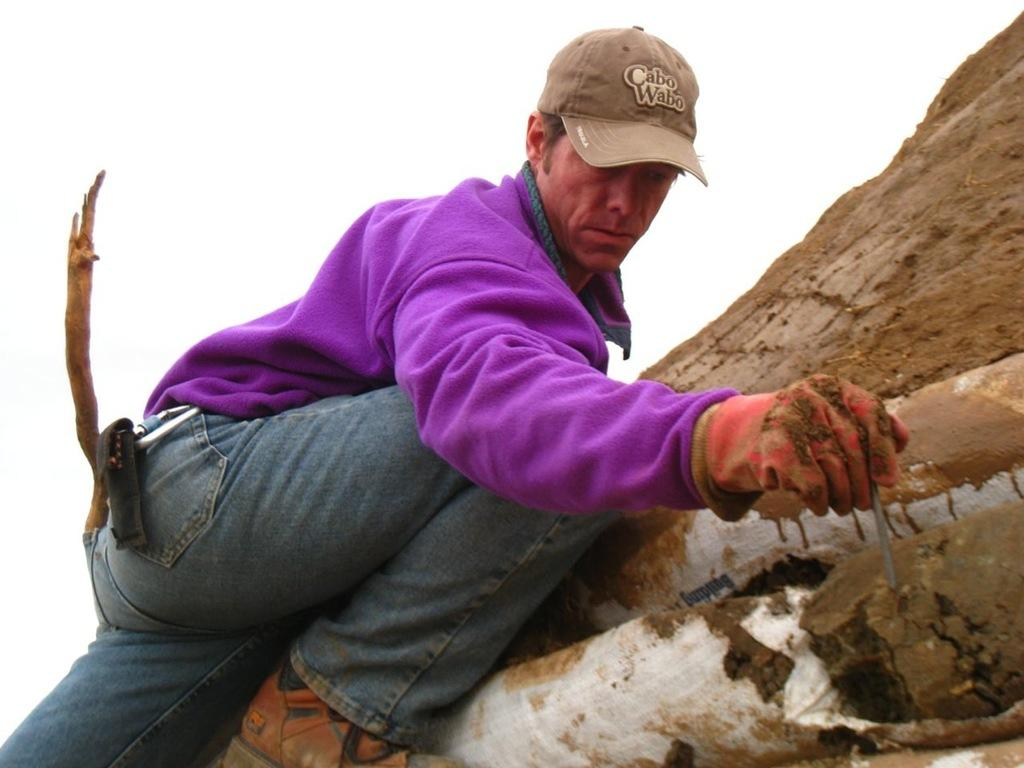What is the main subject of the image? There is a person in the image. What is the person doing in the image? The person is climbing a mountain. What color is the person's shirt? The person is wearing a purple shirt. What color are the person's jeans? The person is wearing blue jeans. What can be seen in the background of the image? The background of the image includes the sky. What color is the sky in the image? The sky is white in color. How many oranges can be seen in the person's backpack in the image? There are no oranges visible in the image, as the person is climbing a mountain and not carrying any fruit. Can you describe the crow that is perched on the person's shoulder in the image? There is no crow present in the image; the person is climbing a mountain alone. 